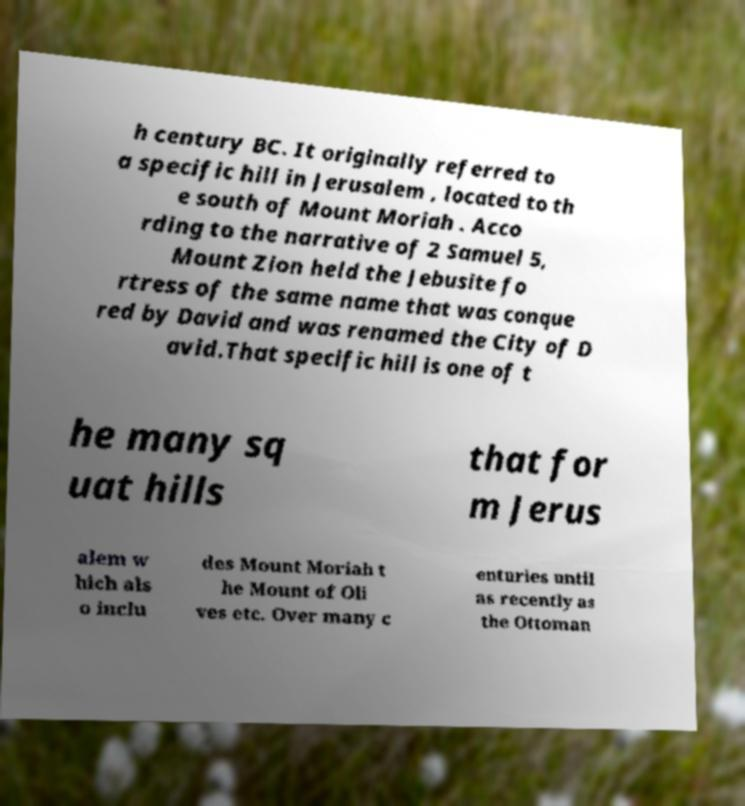There's text embedded in this image that I need extracted. Can you transcribe it verbatim? h century BC. It originally referred to a specific hill in Jerusalem , located to th e south of Mount Moriah . Acco rding to the narrative of 2 Samuel 5, Mount Zion held the Jebusite fo rtress of the same name that was conque red by David and was renamed the City of D avid.That specific hill is one of t he many sq uat hills that for m Jerus alem w hich als o inclu des Mount Moriah t he Mount of Oli ves etc. Over many c enturies until as recently as the Ottoman 